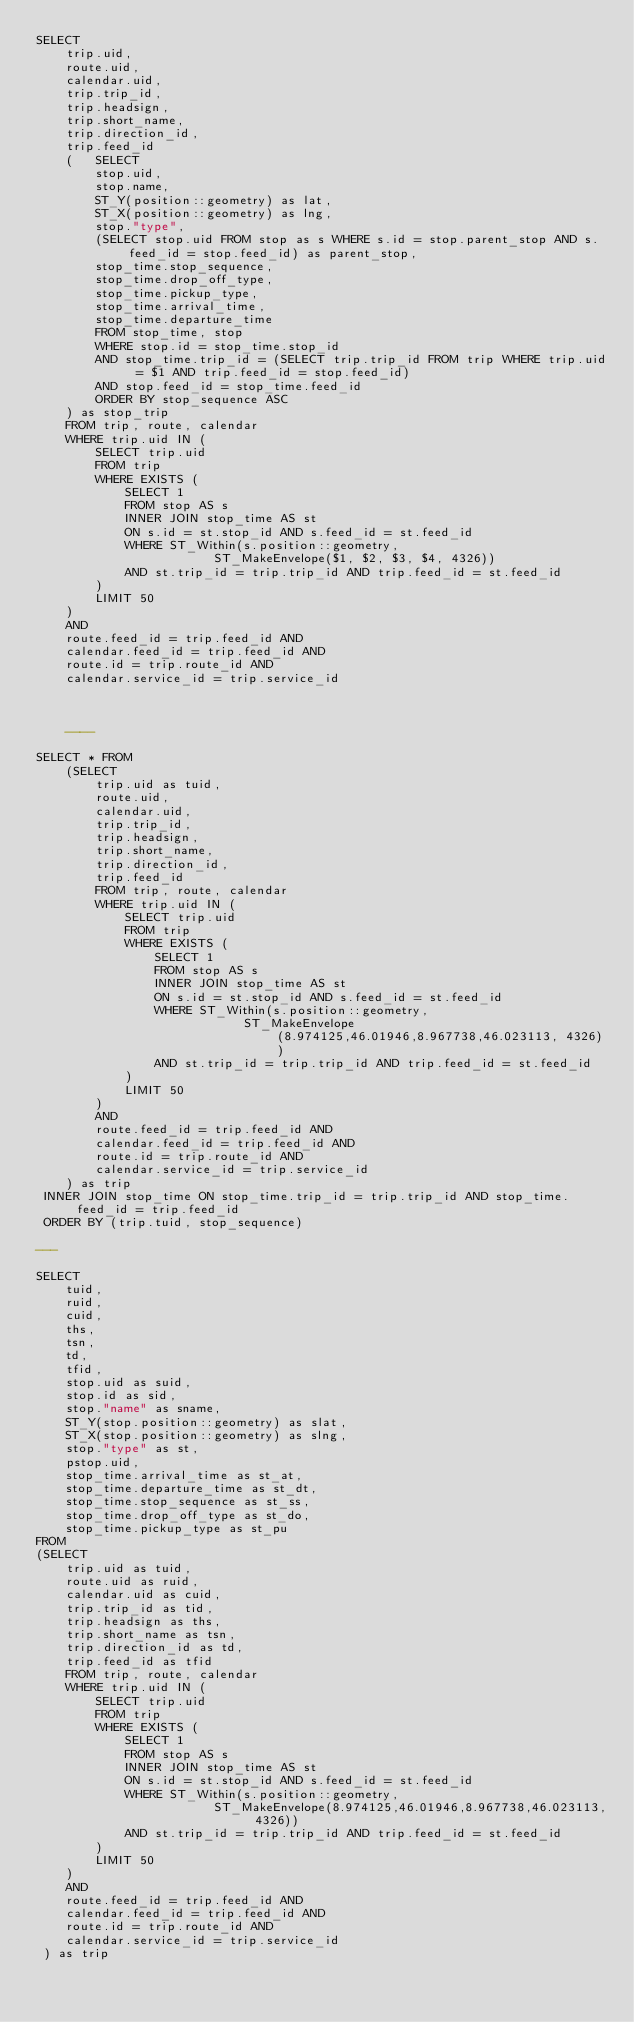Convert code to text. <code><loc_0><loc_0><loc_500><loc_500><_SQL_>SELECT 
    trip.uid,
    route.uid,
    calendar.uid,
    trip.trip_id,
    trip.headsign,
    trip.short_name,
    trip.direction_id,
    trip.feed_id 
    (   SELECT 
        stop.uid, 
        stop.name, 
        ST_Y(position::geometry) as lat,
        ST_X(position::geometry) as lng,
        stop."type", 
        (SELECT stop.uid FROM stop as s WHERE s.id = stop.parent_stop AND s.feed_id = stop.feed_id) as parent_stop, 
        stop_time.stop_sequence,  
        stop_time.drop_off_type,
        stop_time.pickup_type,
        stop_time.arrival_time, 
        stop_time.departure_time 
        FROM stop_time, stop
        WHERE stop.id = stop_time.stop_id
        AND stop_time.trip_id = (SELECT trip.trip_id FROM trip WHERE trip.uid = $1 AND trip.feed_id = stop.feed_id) 
        AND stop.feed_id = stop_time.feed_id 
        ORDER BY stop_sequence ASC
    ) as stop_trip 
    FROM trip, route, calendar 
    WHERE trip.uid IN ( 
        SELECT trip.uid
        FROM trip 
        WHERE EXISTS ( 
            SELECT 1 
            FROM stop AS s 
            INNER JOIN stop_time AS st 
            ON s.id = st.stop_id AND s.feed_id = st.feed_id 
            WHERE ST_Within(s.position::geometry, 
                        ST_MakeEnvelope($1, $2, $3, $4, 4326)) 
            AND st.trip_id = trip.trip_id AND trip.feed_id = st.feed_id 
        ) 
        LIMIT 50 
    ) 
    AND 
    route.feed_id = trip.feed_id AND 
    calendar.feed_id = trip.feed_id AND 
    route.id = trip.route_id AND 
    calendar.service_id = trip.service_id



    ----

SELECT * FROM 
    (SELECT 
        trip.uid as tuid,
        route.uid,
        calendar.uid,
        trip.trip_id,
        trip.headsign,
        trip.short_name,
        trip.direction_id,
        trip.feed_id  
        FROM trip, route, calendar 
        WHERE trip.uid IN ( 
            SELECT trip.uid
            FROM trip 
            WHERE EXISTS ( 
                SELECT 1 
                FROM stop AS s 
                INNER JOIN stop_time AS st 
                ON s.id = st.stop_id AND s.feed_id = st.feed_id 
                WHERE ST_Within(s.position::geometry, 
                            ST_MakeEnvelope(8.974125,46.01946,8.967738,46.023113, 4326))
                AND st.trip_id = trip.trip_id AND trip.feed_id = st.feed_id 
            ) 
            LIMIT 50 
        ) 
        AND 
        route.feed_id = trip.feed_id AND 
        calendar.feed_id = trip.feed_id AND 
        route.id = trip.route_id AND 
        calendar.service_id = trip.service_id
    ) as trip
 INNER JOIN stop_time ON stop_time.trip_id = trip.trip_id AND stop_time.feed_id = trip.feed_id
 ORDER BY (trip.tuid, stop_sequence)

---

SELECT
	tuid,
	ruid,
	cuid,
	ths,
	tsn,
	td,
	tfid,
	stop.uid as suid,
	stop.id as sid,
	stop."name" as sname,
	ST_Y(stop.position::geometry) as slat,
    ST_X(stop.position::geometry) as slng,
    stop."type" as st,
    pstop.uid,
    stop_time.arrival_time as st_at,
	stop_time.departure_time as st_dt,
	stop_time.stop_sequence as st_ss,
	stop_time.drop_off_type as st_do,
	stop_time.pickup_type as st_pu
FROM
(SELECT
    trip.uid as tuid,
    route.uid as ruid,
    calendar.uid as cuid,
    trip.trip_id as tid,
    trip.headsign as ths,
    trip.short_name as tsn,
    trip.direction_id as td,
    trip.feed_id as tfid
    FROM trip, route, calendar
    WHERE trip.uid IN (
        SELECT trip.uid
        FROM trip
        WHERE EXISTS (
            SELECT 1
            FROM stop AS s
            INNER JOIN stop_time AS st
            ON s.id = st.stop_id AND s.feed_id = st.feed_id
            WHERE ST_Within(s.position::geometry,
                        ST_MakeEnvelope(8.974125,46.01946,8.967738,46.023113, 4326))
            AND st.trip_id = trip.trip_id AND trip.feed_id = st.feed_id
        )
        LIMIT 50
    )
    AND
    route.feed_id = trip.feed_id AND
    calendar.feed_id = trip.feed_id AND
    route.id = trip.route_id AND
    calendar.service_id = trip.service_id
 ) as trip</code> 